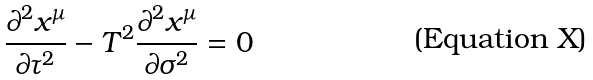Convert formula to latex. <formula><loc_0><loc_0><loc_500><loc_500>\frac { \partial ^ { 2 } x ^ { \mu } } { \partial \tau ^ { 2 } } - T ^ { 2 } \frac { \partial ^ { 2 } x ^ { \mu } } { \partial \sigma ^ { 2 } } = 0</formula> 